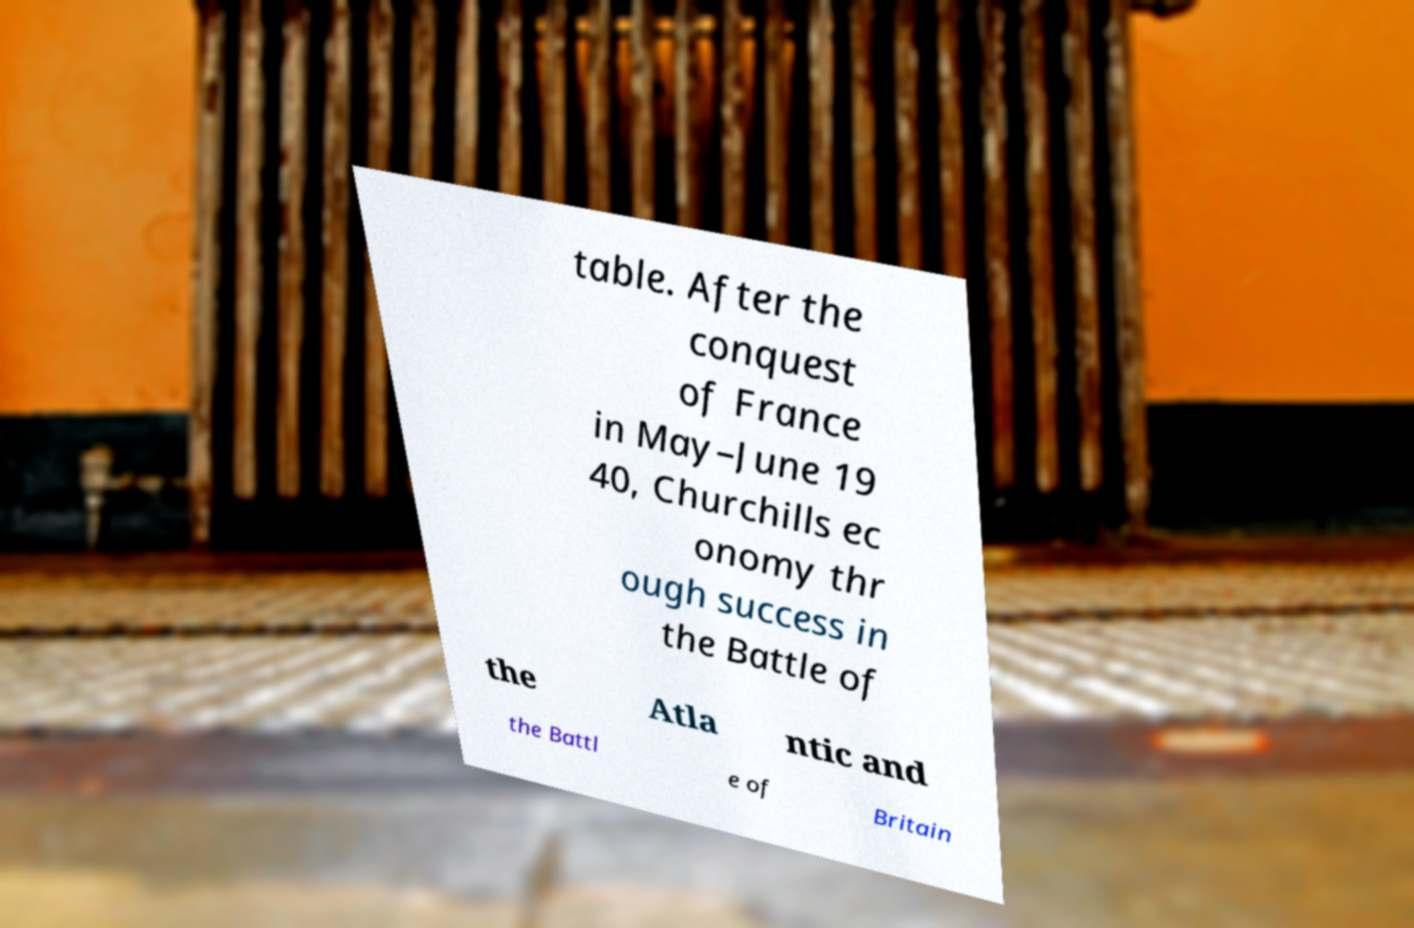Please identify and transcribe the text found in this image. table. After the conquest of France in May–June 19 40, Churchills ec onomy thr ough success in the Battle of the Atla ntic and the Battl e of Britain 